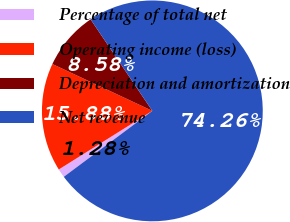Convert chart to OTSL. <chart><loc_0><loc_0><loc_500><loc_500><pie_chart><fcel>Percentage of total net<fcel>Operating income (loss)<fcel>Depreciation and amortization<fcel>Net revenue<nl><fcel>1.28%<fcel>15.88%<fcel>8.58%<fcel>74.26%<nl></chart> 